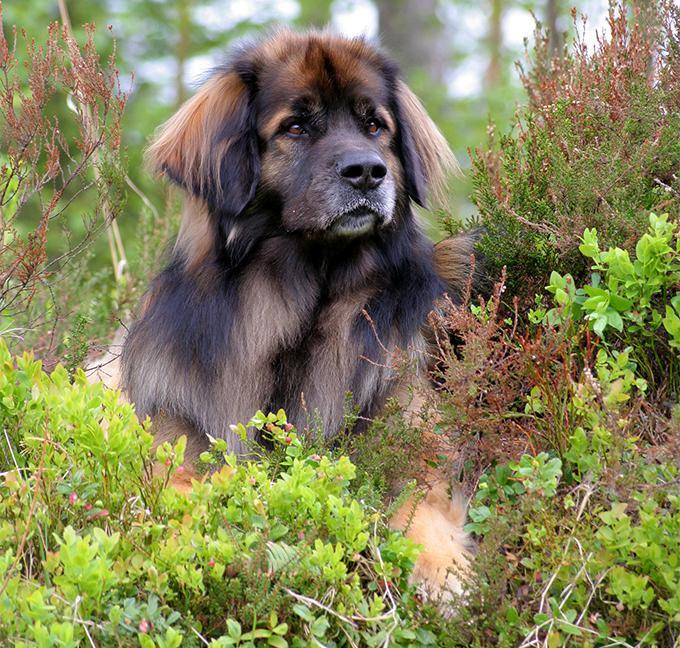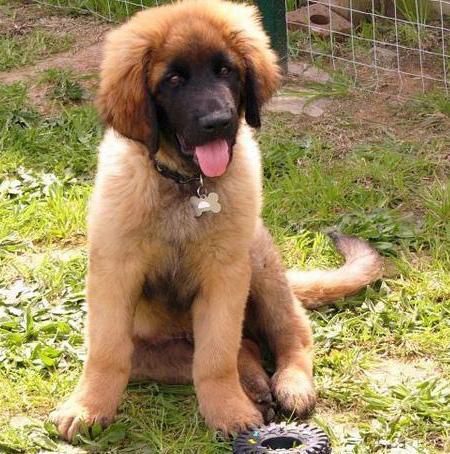The first image is the image on the left, the second image is the image on the right. Analyze the images presented: Is the assertion "Both dogs are outside on the grass." valid? Answer yes or no. Yes. The first image is the image on the left, the second image is the image on the right. For the images shown, is this caption "Right image shows one furry dog in an outdoor area enclosed by wire." true? Answer yes or no. Yes. 